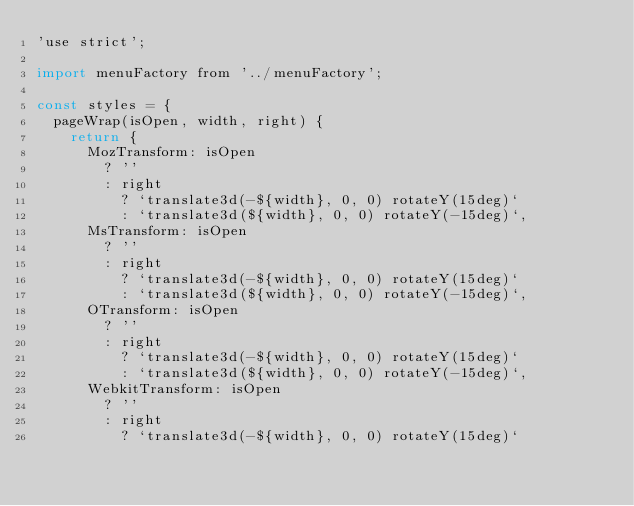Convert code to text. <code><loc_0><loc_0><loc_500><loc_500><_JavaScript_>'use strict';

import menuFactory from '../menuFactory';

const styles = {
  pageWrap(isOpen, width, right) {
    return {
      MozTransform: isOpen
        ? ''
        : right
          ? `translate3d(-${width}, 0, 0) rotateY(15deg)`
          : `translate3d(${width}, 0, 0) rotateY(-15deg)`,
      MsTransform: isOpen
        ? ''
        : right
          ? `translate3d(-${width}, 0, 0) rotateY(15deg)`
          : `translate3d(${width}, 0, 0) rotateY(-15deg)`,
      OTransform: isOpen
        ? ''
        : right
          ? `translate3d(-${width}, 0, 0) rotateY(15deg)`
          : `translate3d(${width}, 0, 0) rotateY(-15deg)`,
      WebkitTransform: isOpen
        ? ''
        : right
          ? `translate3d(-${width}, 0, 0) rotateY(15deg)`</code> 